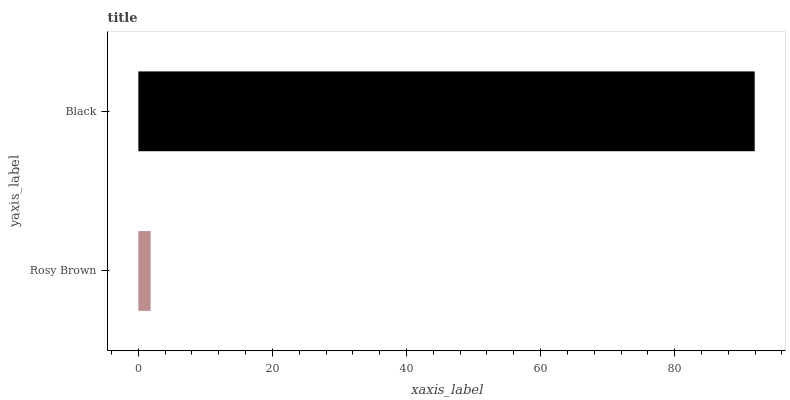Is Rosy Brown the minimum?
Answer yes or no. Yes. Is Black the maximum?
Answer yes or no. Yes. Is Black the minimum?
Answer yes or no. No. Is Black greater than Rosy Brown?
Answer yes or no. Yes. Is Rosy Brown less than Black?
Answer yes or no. Yes. Is Rosy Brown greater than Black?
Answer yes or no. No. Is Black less than Rosy Brown?
Answer yes or no. No. Is Black the high median?
Answer yes or no. Yes. Is Rosy Brown the low median?
Answer yes or no. Yes. Is Rosy Brown the high median?
Answer yes or no. No. Is Black the low median?
Answer yes or no. No. 